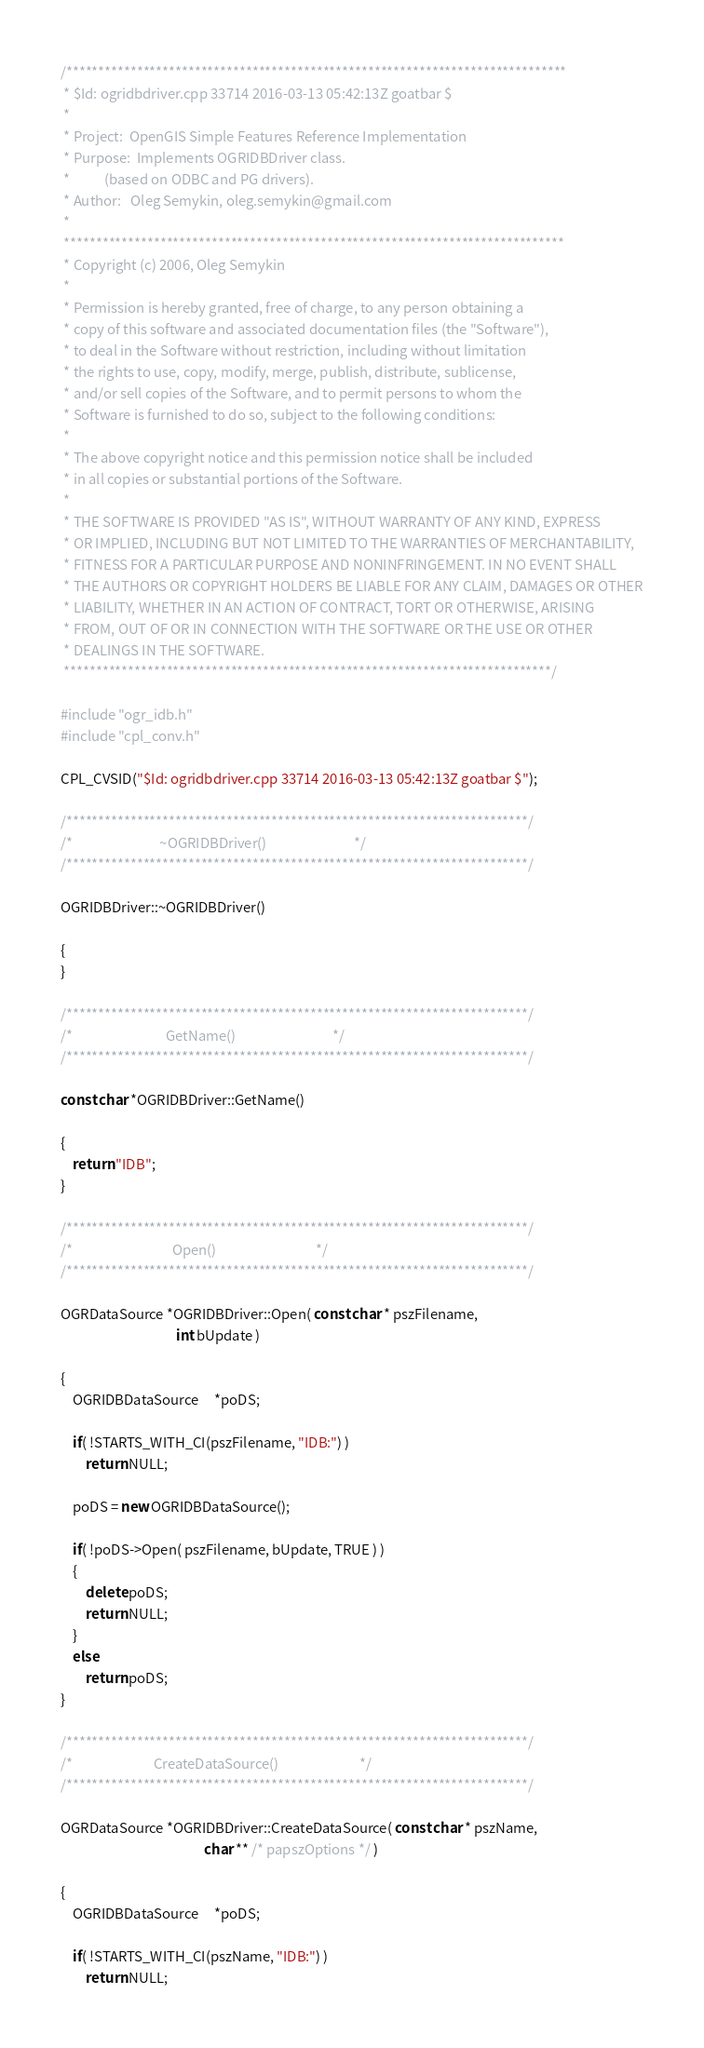<code> <loc_0><loc_0><loc_500><loc_500><_C++_>/******************************************************************************
 * $Id: ogridbdriver.cpp 33714 2016-03-13 05:42:13Z goatbar $
 *
 * Project:  OpenGIS Simple Features Reference Implementation
 * Purpose:  Implements OGRIDBDriver class.
 *           (based on ODBC and PG drivers).
 * Author:   Oleg Semykin, oleg.semykin@gmail.com
 *
 ******************************************************************************
 * Copyright (c) 2006, Oleg Semykin
 *
 * Permission is hereby granted, free of charge, to any person obtaining a
 * copy of this software and associated documentation files (the "Software"),
 * to deal in the Software without restriction, including without limitation
 * the rights to use, copy, modify, merge, publish, distribute, sublicense,
 * and/or sell copies of the Software, and to permit persons to whom the
 * Software is furnished to do so, subject to the following conditions:
 *
 * The above copyright notice and this permission notice shall be included
 * in all copies or substantial portions of the Software.
 *
 * THE SOFTWARE IS PROVIDED "AS IS", WITHOUT WARRANTY OF ANY KIND, EXPRESS
 * OR IMPLIED, INCLUDING BUT NOT LIMITED TO THE WARRANTIES OF MERCHANTABILITY,
 * FITNESS FOR A PARTICULAR PURPOSE AND NONINFRINGEMENT. IN NO EVENT SHALL
 * THE AUTHORS OR COPYRIGHT HOLDERS BE LIABLE FOR ANY CLAIM, DAMAGES OR OTHER
 * LIABILITY, WHETHER IN AN ACTION OF CONTRACT, TORT OR OTHERWISE, ARISING
 * FROM, OUT OF OR IN CONNECTION WITH THE SOFTWARE OR THE USE OR OTHER
 * DEALINGS IN THE SOFTWARE.
 ****************************************************************************/

#include "ogr_idb.h"
#include "cpl_conv.h"

CPL_CVSID("$Id: ogridbdriver.cpp 33714 2016-03-13 05:42:13Z goatbar $");

/************************************************************************/
/*                            ~OGRIDBDriver()                            */
/************************************************************************/

OGRIDBDriver::~OGRIDBDriver()

{
}

/************************************************************************/
/*                              GetName()                               */
/************************************************************************/

const char *OGRIDBDriver::GetName()

{
    return "IDB";
}

/************************************************************************/
/*                                Open()                                */
/************************************************************************/

OGRDataSource *OGRIDBDriver::Open( const char * pszFilename,
                                     int bUpdate )

{
    OGRIDBDataSource     *poDS;

    if( !STARTS_WITH_CI(pszFilename, "IDB:") )
        return NULL;

    poDS = new OGRIDBDataSource();

    if( !poDS->Open( pszFilename, bUpdate, TRUE ) )
    {
        delete poDS;
        return NULL;
    }
    else
        return poDS;
}

/************************************************************************/
/*                          CreateDataSource()                          */
/************************************************************************/

OGRDataSource *OGRIDBDriver::CreateDataSource( const char * pszName,
                                              char ** /* papszOptions */ )

{
    OGRIDBDataSource     *poDS;

    if( !STARTS_WITH_CI(pszName, "IDB:") )
        return NULL;
</code> 